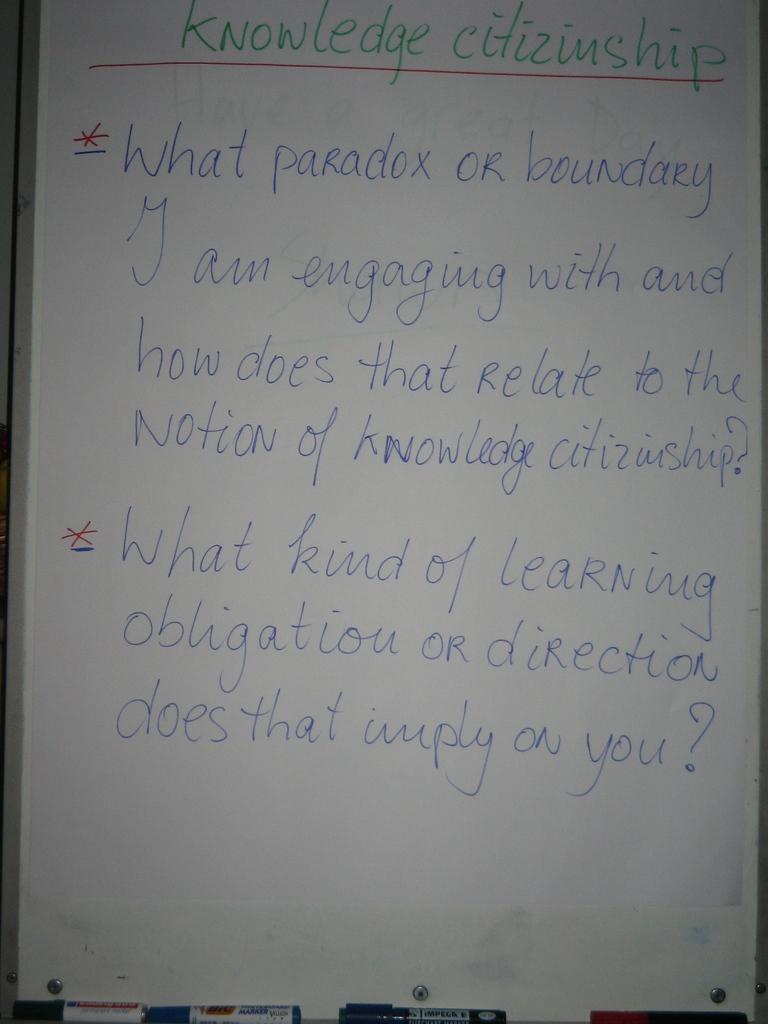What color are the words written in one the board?
Ensure brevity in your answer.  Blue. 